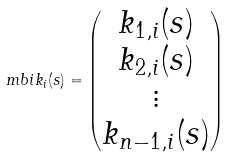Convert formula to latex. <formula><loc_0><loc_0><loc_500><loc_500>\ m b i { k } _ { i } ( s ) = \begin{pmatrix} k _ { 1 , i } ( s ) \\ k _ { 2 , i } ( s ) \\ \vdots \\ k _ { n - 1 , i } ( s ) \end{pmatrix}</formula> 